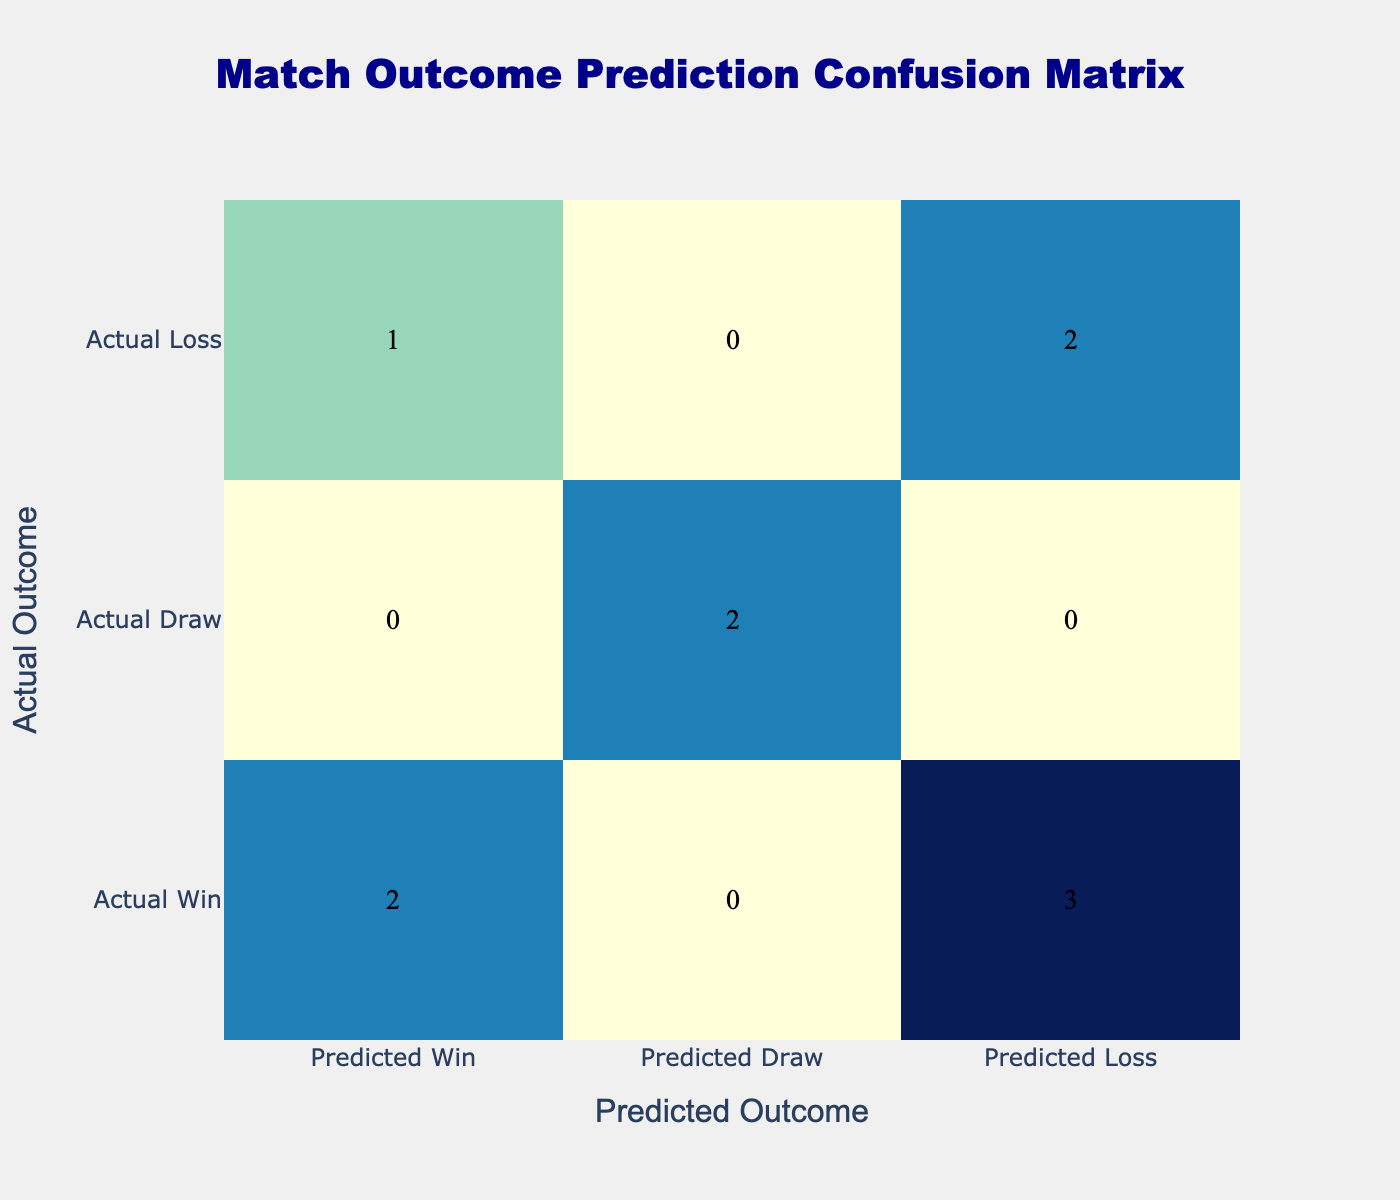What is the total number of matches that ended in a Win? To find the total number of matches that ended in a Win, I look at the row entries for 'Match Outcome' that show "Win". There are five players (Emma Hayes, Fran Kirby, Jessie Fleming, Beth England, and Zoe McDaniel) who contributed to a Win, resulting in a total of 5 Wins.
Answer: 5 What was the predicted outcome for Sam Kerr based on her statistics? The prediction for Sam Kerr was made by comparing her Goals and Tackles. With 12 goals (more than 10), she would initially be predicted to Win. However, since she lost the match, the predicted outcome based on her goals is a Loss.
Answer: Loss Did any player have a match predicted as a Win but actually resulted in a Loss? Yes, Sam Kerr had her match predicted as a Win due to her scoring 12 goals, but the actual outcome was a Loss.
Answer: Yes How many players had a match outcome of Draw? To find the total number of players with a match outcome of Draw, I review the 'Match Outcome' column for entries labeled as "Draw". There are two players (Millie Bright and Maria Thorisdottir) with Draw outcomes.
Answer: 2 What is the average number of assists for matches that ended in a Win? For players with a Win outcome (Emma Hayes, Fran Kirby, Jessie Fleming, Beth England, Zoe McDaniel), their assists are 5, 8, 4, 7, and 5, respectively. I sum these up to get 29 assists. Dividing this by the number of players (5) gives an average of 29/5 = 5.8.
Answer: 5.8 What proportion of matches were predicted as Draw? To calculate the proportion of matches predicted as Draw, I need to find out how many matches have been predicted as Draw. The row entries show one case (Millie Bright). The total number of matches is 10, so the proportion is 1/10, which equals 0.1 or 10%.
Answer: 10% How many players predicted to win had an actual outcome of a Loss? Looking at the confusion matrix, I analyze the predicted outcomes labeled as "Win" and find that Sam Kerr (predicted Win) actually lost the match, resulting in a total of one player facing this situation.
Answer: 1 What is the difference in the number of Predictions for Win and Loss outcomes? The total predictions for Wins (5) and Losses (3) need to be calculated. Therefore, the difference is obtained by subtracting the number of Loss predictions from Win predictions: 5 - 3 = 2.
Answer: 2 Were there more Wins or Losses predicted? By examining the predictions made in the confusion matrix, there are 5 predicted Wins and 3 predicted Losses. Since 5 is greater than 3, it indicates that there were more Wins predicted than Losses.
Answer: More Wins 